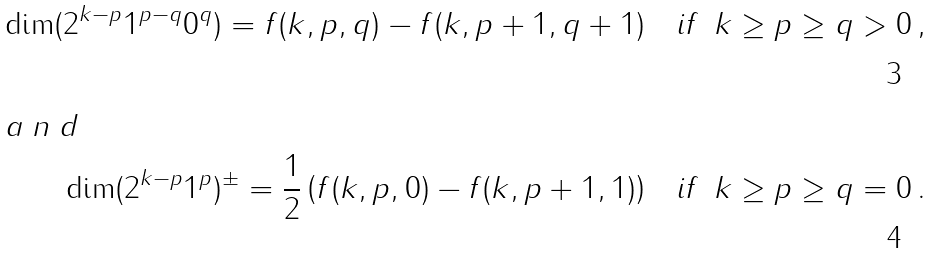Convert formula to latex. <formula><loc_0><loc_0><loc_500><loc_500>\dim ( 2 ^ { k - p } 1 ^ { p - q } 0 ^ { q } ) = f ( k , p , q ) - f ( k , p + 1 , q + 1 ) & \quad \text {if\ } \ k \geq p \geq q > 0 \, , \\ \intertext { a n d } \dim ( 2 ^ { k - p } 1 ^ { p } ) ^ { \pm } = \frac { 1 } { 2 } \left ( f ( k , p , 0 ) - f ( k , p + 1 , 1 ) \right ) & \quad \text {if\ } \ k \geq p \geq q = 0 \, .</formula> 